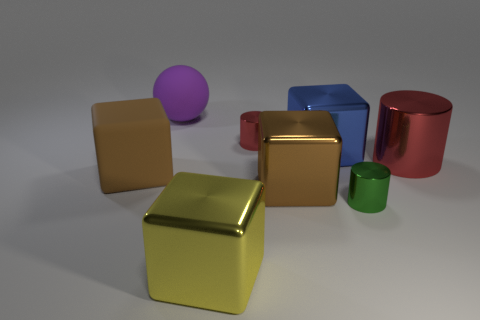Is the color of the tiny object behind the large red metal cylinder the same as the large metallic cylinder that is behind the large yellow object?
Ensure brevity in your answer.  Yes. There is a small metal object in front of the brown cube that is in front of the large brown matte thing; what is its shape?
Provide a succinct answer. Cylinder. What number of other things are the same color as the large rubber block?
Give a very brief answer. 1. Is the big brown cube that is right of the large yellow metallic cube made of the same material as the large red cylinder behind the large yellow shiny thing?
Give a very brief answer. Yes. There is a green metal cylinder to the right of the tiny red cylinder; how big is it?
Provide a short and direct response. Small. What material is the other brown object that is the same shape as the brown rubber thing?
Your response must be concise. Metal. There is a big brown object that is right of the brown rubber thing; what is its shape?
Your answer should be very brief. Cube. How many brown metal things are the same shape as the blue object?
Keep it short and to the point. 1. Are there an equal number of big brown metallic objects right of the large metal cylinder and big matte things that are on the left side of the purple rubber object?
Offer a terse response. No. Are there any green cylinders made of the same material as the big yellow cube?
Your answer should be compact. Yes. 